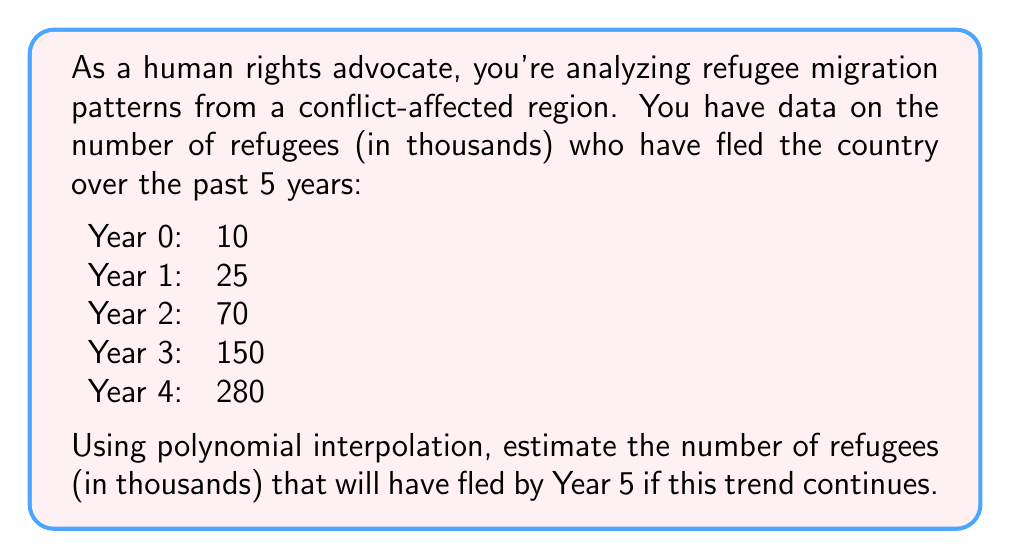Can you answer this question? To solve this problem, we'll use Lagrange polynomial interpolation to find a 4th-degree polynomial that fits the given data points. Then, we'll use this polynomial to estimate the number of refugees at Year 5.

1. The Lagrange interpolation polynomial is given by:

   $$P(x) = \sum_{i=0}^{n} y_i \cdot L_i(x)$$

   where $L_i(x)$ is the Lagrange basis polynomial:

   $$L_i(x) = \prod_{j=0, j \neq i}^{n} \frac{x - x_j}{x_i - x_j}$$

2. For our data:
   $(x_0, y_0) = (0, 10)$
   $(x_1, y_1) = (1, 25)$
   $(x_2, y_2) = (2, 70)$
   $(x_3, y_3) = (3, 150)$
   $(x_4, y_4) = (4, 280)$

3. Calculating each $L_i(x)$:

   $$L_0(x) = \frac{(x-1)(x-2)(x-3)(x-4)}{(0-1)(0-2)(0-3)(0-4)} = \frac{x^4 - 10x^3 + 35x^2 - 50x + 24}{24}$$
   
   $$L_1(x) = \frac{(x-0)(x-2)(x-3)(x-4)}{(1-0)(1-2)(1-3)(1-4)} = -\frac{x^4 - 9x^3 + 26x^2 - 24x}{6}$$
   
   $$L_2(x) = \frac{(x-0)(x-1)(x-3)(x-4)}{(2-0)(2-1)(2-3)(2-4)} = \frac{x^4 - 8x^3 + 19x^2 - 12x}{4}$$
   
   $$L_3(x) = \frac{(x-0)(x-1)(x-2)(x-4)}{(3-0)(3-1)(3-2)(3-4)} = -\frac{x^4 - 7x^3 + 14x^2 - 8x}{6}$$
   
   $$L_4(x) = \frac{(x-0)(x-1)(x-2)(x-3)}{(4-0)(4-1)(4-2)(4-3)} = \frac{x^4 - 6x^3 + 11x^2 - 6x}{24}$$

4. Constructing the interpolation polynomial:

   $$P(x) = 10L_0(x) + 25L_1(x) + 70L_2(x) + 150L_3(x) + 280L_4(x)$$

5. Simplifying and combining like terms:

   $$P(x) = \frac{5}{6}x^4 - \frac{5}{2}x^3 + \frac{35}{3}x^2 + 5x + 10$$

6. To estimate the number of refugees at Year 5, we evaluate $P(5)$:

   $$P(5) = \frac{5}{6}(625) - \frac{5}{2}(125) + \frac{35}{3}(25) + 5(5) + 10$$
   
   $$= 520.8333 - 312.5 + 291.6667 + 25 + 10$$
   
   $$= 534.9999 \approx 535$$

Therefore, the estimated number of refugees by Year 5 is approximately 535 thousand.
Answer: 535 thousand refugees 